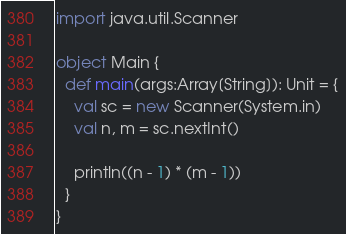<code> <loc_0><loc_0><loc_500><loc_500><_Scala_>import java.util.Scanner

object Main {
  def main(args:Array[String]): Unit = {
    val sc = new Scanner(System.in)
    val n, m = sc.nextInt()

    println((n - 1) * (m - 1))
  }
}</code> 